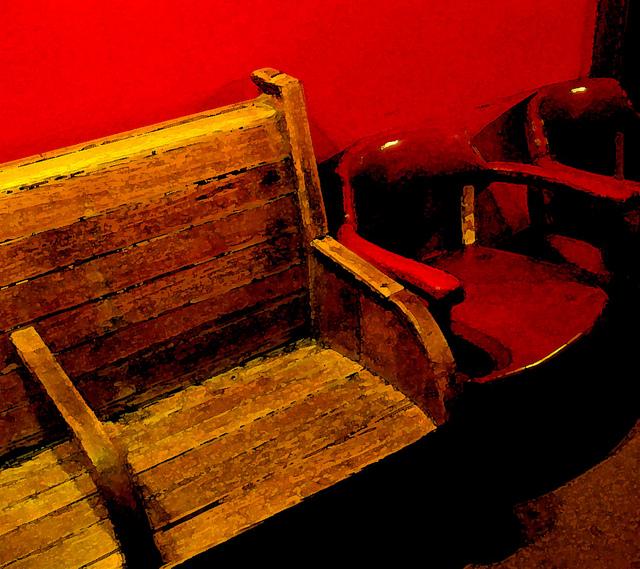Is this an older bench?
Keep it brief. Yes. What color are the walls and the chairs?
Quick response, please. Red. Does this bench have legs?
Give a very brief answer. Yes. 